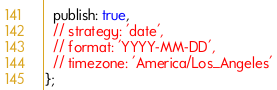Convert code to text. <code><loc_0><loc_0><loc_500><loc_500><_JavaScript_>  publish: true,
  // strategy: 'date',
  // format: 'YYYY-MM-DD',
  // timezone: 'America/Los_Angeles'
};
</code> 